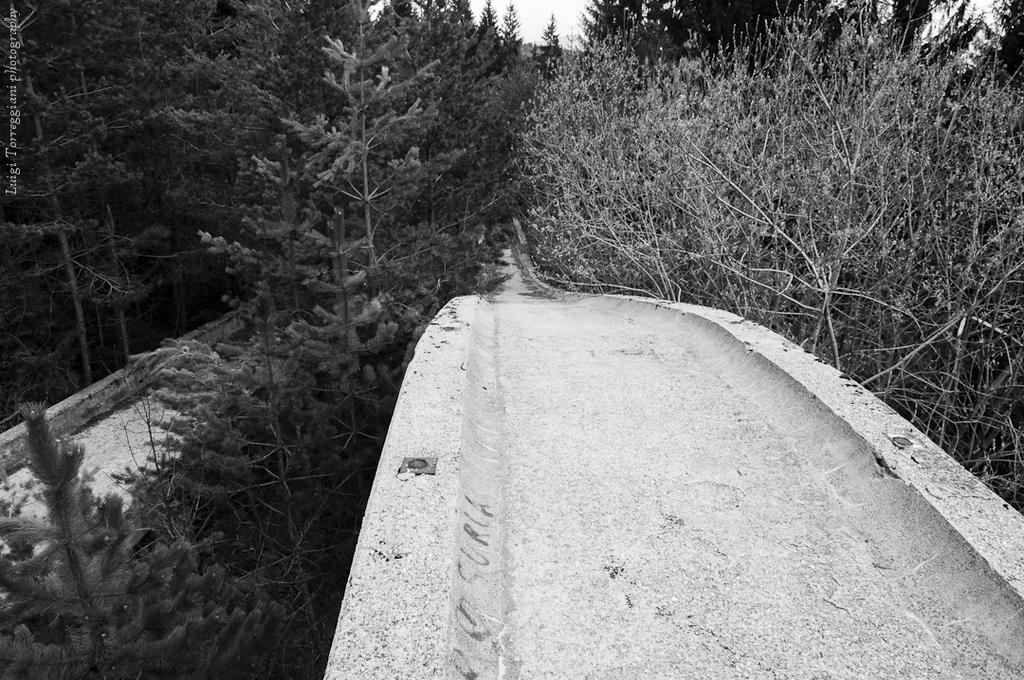What can be seen in the foreground of the image? There is a path in the foreground of the image. What is visible in the background of the image? Trees and the sky are visible in the background of the image. Can you describe the text on the left side of the image? Unfortunately, the provided facts do not give any information about the text, so we cannot describe it. How many cows are grazing on the path in the image? There are no cows present in the image; the path is empty. Is there a bike leaning against the trees in the background of the image? There is no bike present in the image; only trees and the sky are visible in the background. 